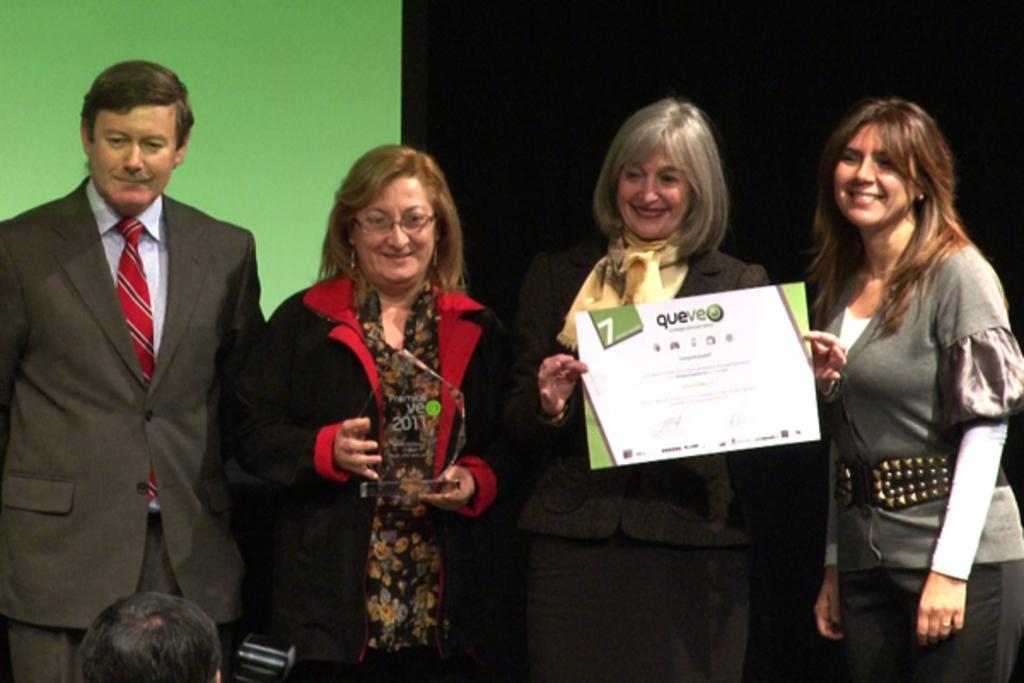Could you give a brief overview of what you see in this image? In this image there are group of persons standing and smiling. In the front the person head is visible and there is an object which is black in colour. In the background there is a wall which is green in colour. In the center the woman is standing and holding a paper in her hand and smiling. 